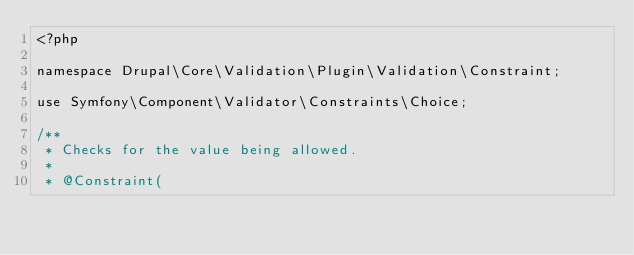Convert code to text. <code><loc_0><loc_0><loc_500><loc_500><_PHP_><?php

namespace Drupal\Core\Validation\Plugin\Validation\Constraint;

use Symfony\Component\Validator\Constraints\Choice;

/**
 * Checks for the value being allowed.
 *
 * @Constraint(</code> 